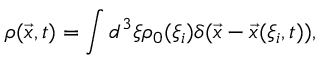Convert formula to latex. <formula><loc_0><loc_0><loc_500><loc_500>\rho ( \vec { x } , t ) = \int d ^ { 3 } \xi \rho _ { 0 } ( \xi _ { i } ) \delta ( \vec { x } - \vec { x } ( \xi _ { i } , t ) ) ,</formula> 